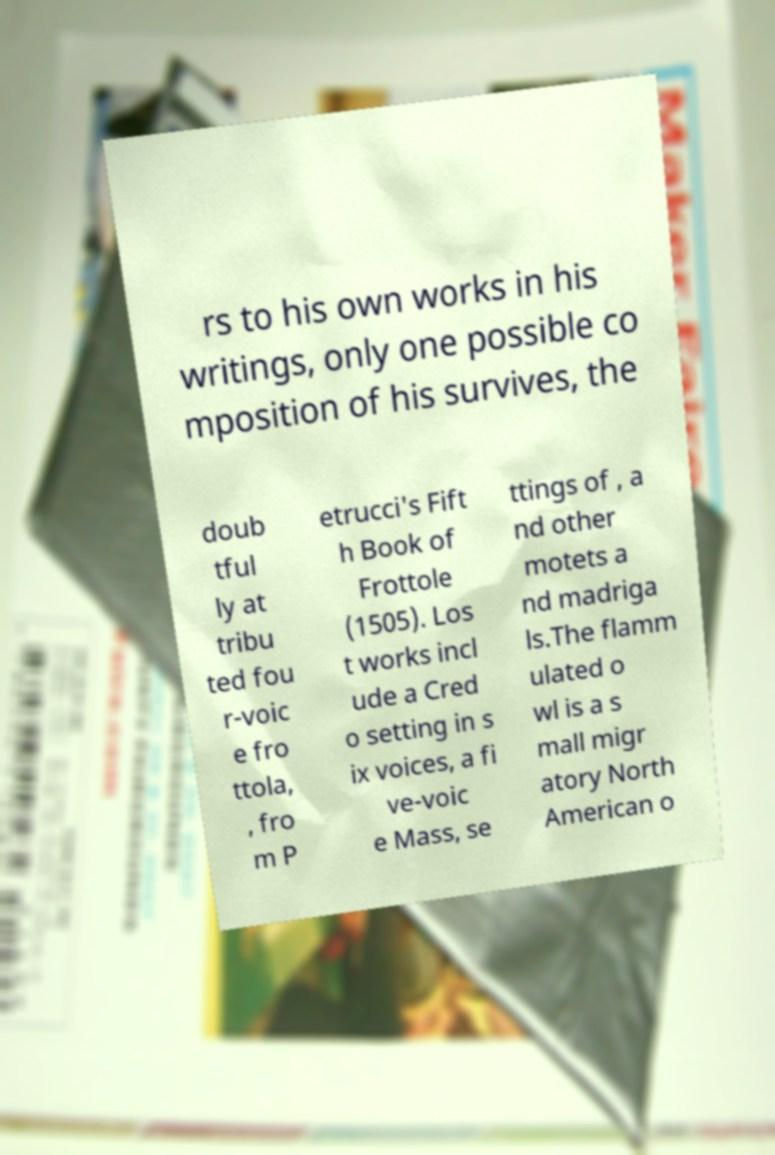There's text embedded in this image that I need extracted. Can you transcribe it verbatim? rs to his own works in his writings, only one possible co mposition of his survives, the doub tful ly at tribu ted fou r-voic e fro ttola, , fro m P etrucci's Fift h Book of Frottole (1505). Los t works incl ude a Cred o setting in s ix voices, a fi ve-voic e Mass, se ttings of , a nd other motets a nd madriga ls.The flamm ulated o wl is a s mall migr atory North American o 